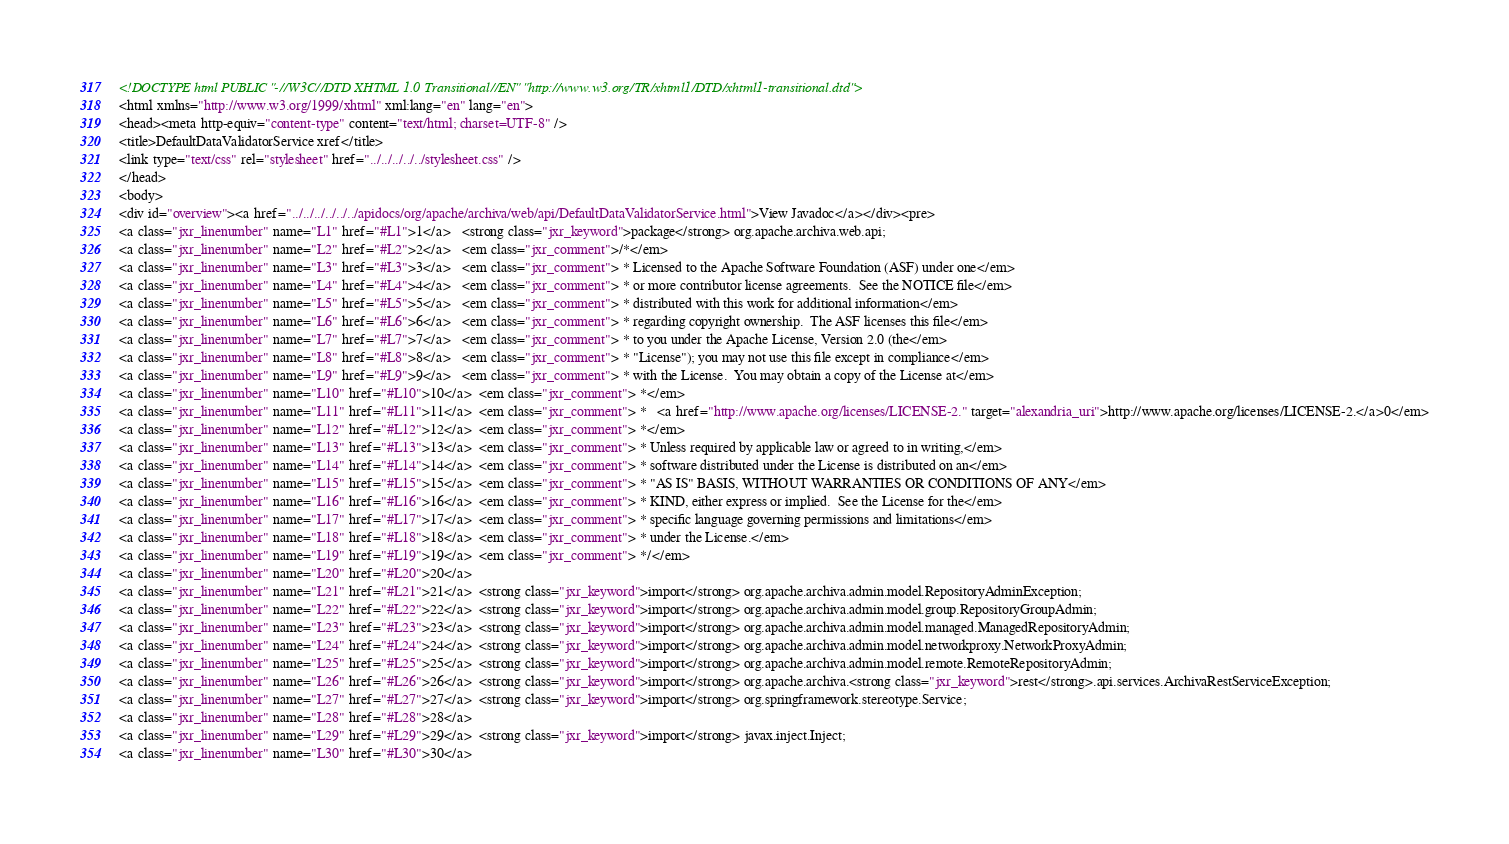Convert code to text. <code><loc_0><loc_0><loc_500><loc_500><_HTML_><!DOCTYPE html PUBLIC "-//W3C//DTD XHTML 1.0 Transitional//EN" "http://www.w3.org/TR/xhtml1/DTD/xhtml1-transitional.dtd">
<html xmlns="http://www.w3.org/1999/xhtml" xml:lang="en" lang="en">
<head><meta http-equiv="content-type" content="text/html; charset=UTF-8" />
<title>DefaultDataValidatorService xref</title>
<link type="text/css" rel="stylesheet" href="../../../../../stylesheet.css" />
</head>
<body>
<div id="overview"><a href="../../../../../../apidocs/org/apache/archiva/web/api/DefaultDataValidatorService.html">View Javadoc</a></div><pre>
<a class="jxr_linenumber" name="L1" href="#L1">1</a>   <strong class="jxr_keyword">package</strong> org.apache.archiva.web.api;
<a class="jxr_linenumber" name="L2" href="#L2">2</a>   <em class="jxr_comment">/*</em>
<a class="jxr_linenumber" name="L3" href="#L3">3</a>   <em class="jxr_comment"> * Licensed to the Apache Software Foundation (ASF) under one</em>
<a class="jxr_linenumber" name="L4" href="#L4">4</a>   <em class="jxr_comment"> * or more contributor license agreements.  See the NOTICE file</em>
<a class="jxr_linenumber" name="L5" href="#L5">5</a>   <em class="jxr_comment"> * distributed with this work for additional information</em>
<a class="jxr_linenumber" name="L6" href="#L6">6</a>   <em class="jxr_comment"> * regarding copyright ownership.  The ASF licenses this file</em>
<a class="jxr_linenumber" name="L7" href="#L7">7</a>   <em class="jxr_comment"> * to you under the Apache License, Version 2.0 (the</em>
<a class="jxr_linenumber" name="L8" href="#L8">8</a>   <em class="jxr_comment"> * "License"); you may not use this file except in compliance</em>
<a class="jxr_linenumber" name="L9" href="#L9">9</a>   <em class="jxr_comment"> * with the License.  You may obtain a copy of the License at</em>
<a class="jxr_linenumber" name="L10" href="#L10">10</a>  <em class="jxr_comment"> *</em>
<a class="jxr_linenumber" name="L11" href="#L11">11</a>  <em class="jxr_comment"> *   <a href="http://www.apache.org/licenses/LICENSE-2." target="alexandria_uri">http://www.apache.org/licenses/LICENSE-2.</a>0</em>
<a class="jxr_linenumber" name="L12" href="#L12">12</a>  <em class="jxr_comment"> *</em>
<a class="jxr_linenumber" name="L13" href="#L13">13</a>  <em class="jxr_comment"> * Unless required by applicable law or agreed to in writing,</em>
<a class="jxr_linenumber" name="L14" href="#L14">14</a>  <em class="jxr_comment"> * software distributed under the License is distributed on an</em>
<a class="jxr_linenumber" name="L15" href="#L15">15</a>  <em class="jxr_comment"> * "AS IS" BASIS, WITHOUT WARRANTIES OR CONDITIONS OF ANY</em>
<a class="jxr_linenumber" name="L16" href="#L16">16</a>  <em class="jxr_comment"> * KIND, either express or implied.  See the License for the</em>
<a class="jxr_linenumber" name="L17" href="#L17">17</a>  <em class="jxr_comment"> * specific language governing permissions and limitations</em>
<a class="jxr_linenumber" name="L18" href="#L18">18</a>  <em class="jxr_comment"> * under the License.</em>
<a class="jxr_linenumber" name="L19" href="#L19">19</a>  <em class="jxr_comment"> */</em>
<a class="jxr_linenumber" name="L20" href="#L20">20</a>  
<a class="jxr_linenumber" name="L21" href="#L21">21</a>  <strong class="jxr_keyword">import</strong> org.apache.archiva.admin.model.RepositoryAdminException;
<a class="jxr_linenumber" name="L22" href="#L22">22</a>  <strong class="jxr_keyword">import</strong> org.apache.archiva.admin.model.group.RepositoryGroupAdmin;
<a class="jxr_linenumber" name="L23" href="#L23">23</a>  <strong class="jxr_keyword">import</strong> org.apache.archiva.admin.model.managed.ManagedRepositoryAdmin;
<a class="jxr_linenumber" name="L24" href="#L24">24</a>  <strong class="jxr_keyword">import</strong> org.apache.archiva.admin.model.networkproxy.NetworkProxyAdmin;
<a class="jxr_linenumber" name="L25" href="#L25">25</a>  <strong class="jxr_keyword">import</strong> org.apache.archiva.admin.model.remote.RemoteRepositoryAdmin;
<a class="jxr_linenumber" name="L26" href="#L26">26</a>  <strong class="jxr_keyword">import</strong> org.apache.archiva.<strong class="jxr_keyword">rest</strong>.api.services.ArchivaRestServiceException;
<a class="jxr_linenumber" name="L27" href="#L27">27</a>  <strong class="jxr_keyword">import</strong> org.springframework.stereotype.Service;
<a class="jxr_linenumber" name="L28" href="#L28">28</a>  
<a class="jxr_linenumber" name="L29" href="#L29">29</a>  <strong class="jxr_keyword">import</strong> javax.inject.Inject;
<a class="jxr_linenumber" name="L30" href="#L30">30</a>  </code> 